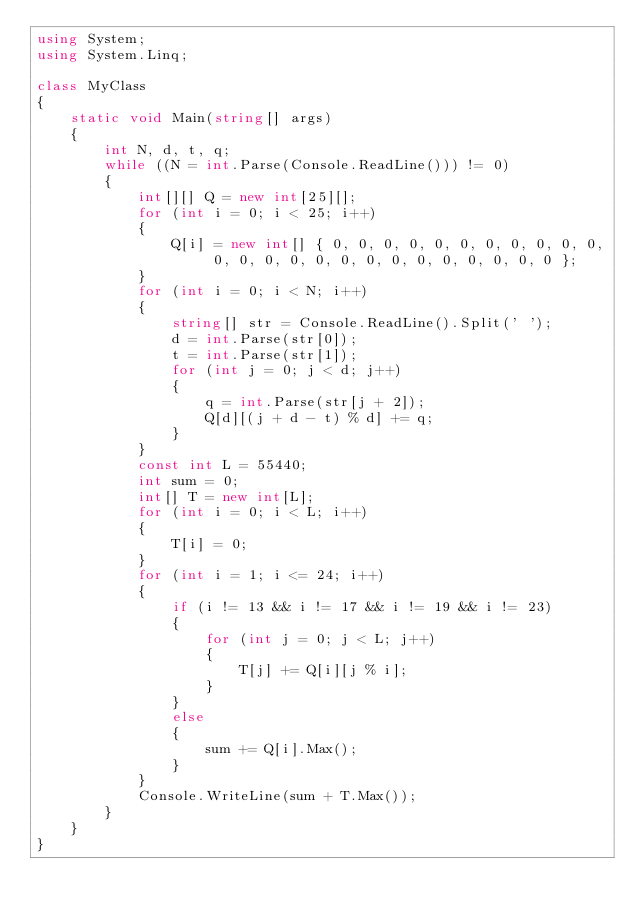Convert code to text. <code><loc_0><loc_0><loc_500><loc_500><_C#_>using System;
using System.Linq;

class MyClass
{
    static void Main(string[] args)
    {
        int N, d, t, q;
        while ((N = int.Parse(Console.ReadLine())) != 0)
        {
            int[][] Q = new int[25][];
            for (int i = 0; i < 25; i++)
            {
                Q[i] = new int[] { 0, 0, 0, 0, 0, 0, 0, 0, 0, 0, 0, 0, 0, 0, 0, 0, 0, 0, 0, 0, 0, 0, 0, 0, 0 };
            }
            for (int i = 0; i < N; i++)
            {
                string[] str = Console.ReadLine().Split(' ');
                d = int.Parse(str[0]);
                t = int.Parse(str[1]);
                for (int j = 0; j < d; j++)
                {
                    q = int.Parse(str[j + 2]);
                    Q[d][(j + d - t) % d] += q;
                }
            }
            const int L = 55440;
            int sum = 0;
            int[] T = new int[L];
            for (int i = 0; i < L; i++)
            {
                T[i] = 0;
            }
            for (int i = 1; i <= 24; i++)
            {
                if (i != 13 && i != 17 && i != 19 && i != 23)
                {
                    for (int j = 0; j < L; j++)
                    {
                        T[j] += Q[i][j % i];
                    }
                }
                else
                {
                    sum += Q[i].Max();
                }
            }
            Console.WriteLine(sum + T.Max());
        }
    }
}
</code> 